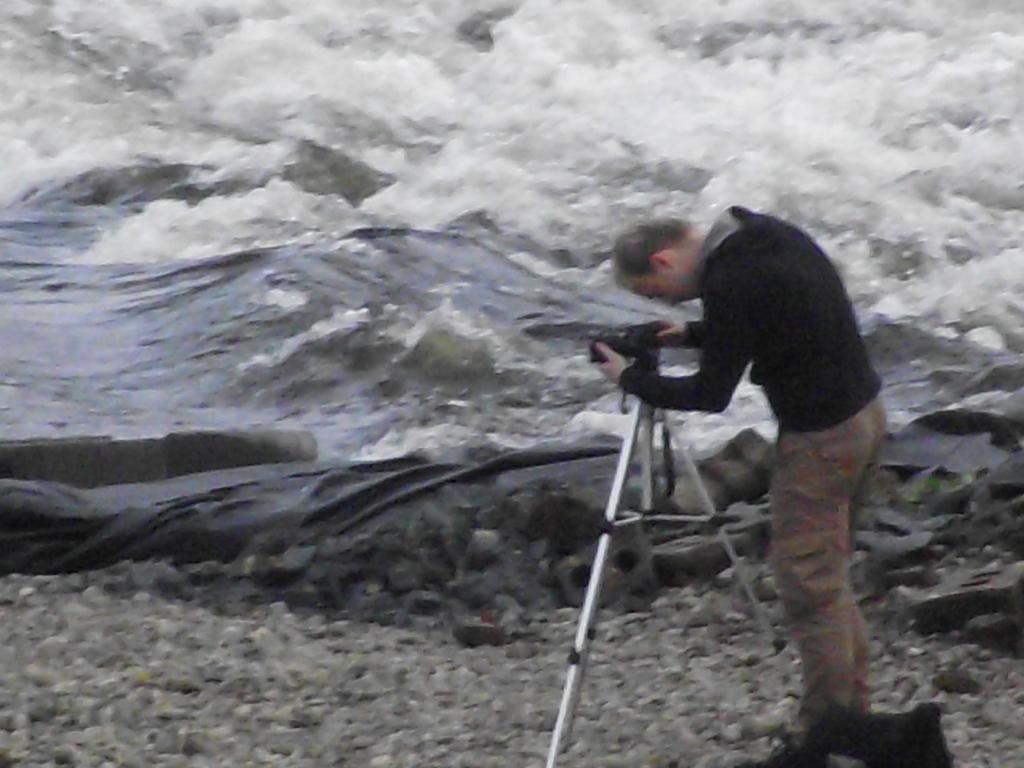In one or two sentences, can you explain what this image depicts? The man on the right corner of the picture wearing black jacket is holding camera and he is taking picture on the camera. Beside him, we see a black color sheet and water. This water might be in sea. At the bottom of the picture, we see stones. 